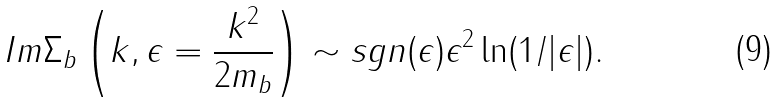Convert formula to latex. <formula><loc_0><loc_0><loc_500><loc_500>I m \Sigma _ { b } \left ( k , \epsilon = \frac { k ^ { 2 } } { 2 m _ { b } } \right ) \sim s g n ( \epsilon ) \epsilon ^ { 2 } \ln ( 1 / | \epsilon | ) .</formula> 